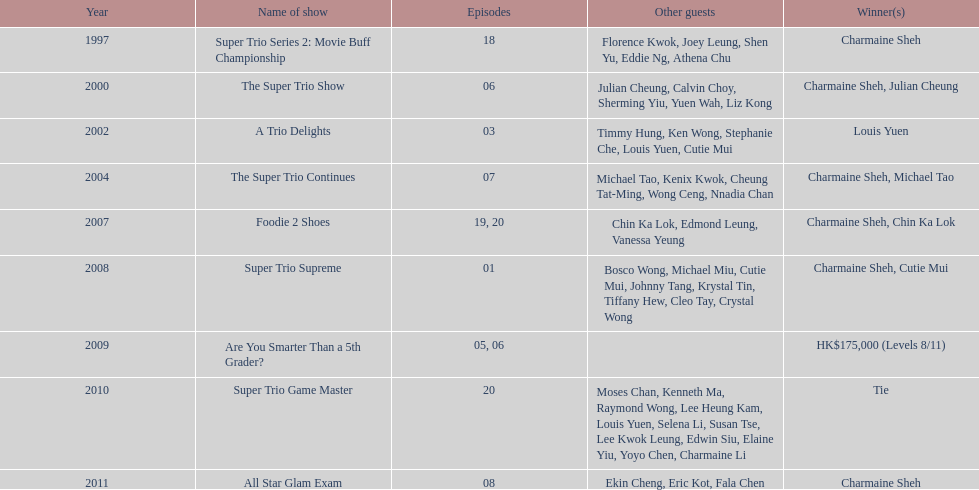How many tv shows has charmaine sheh been featured in? 9. 